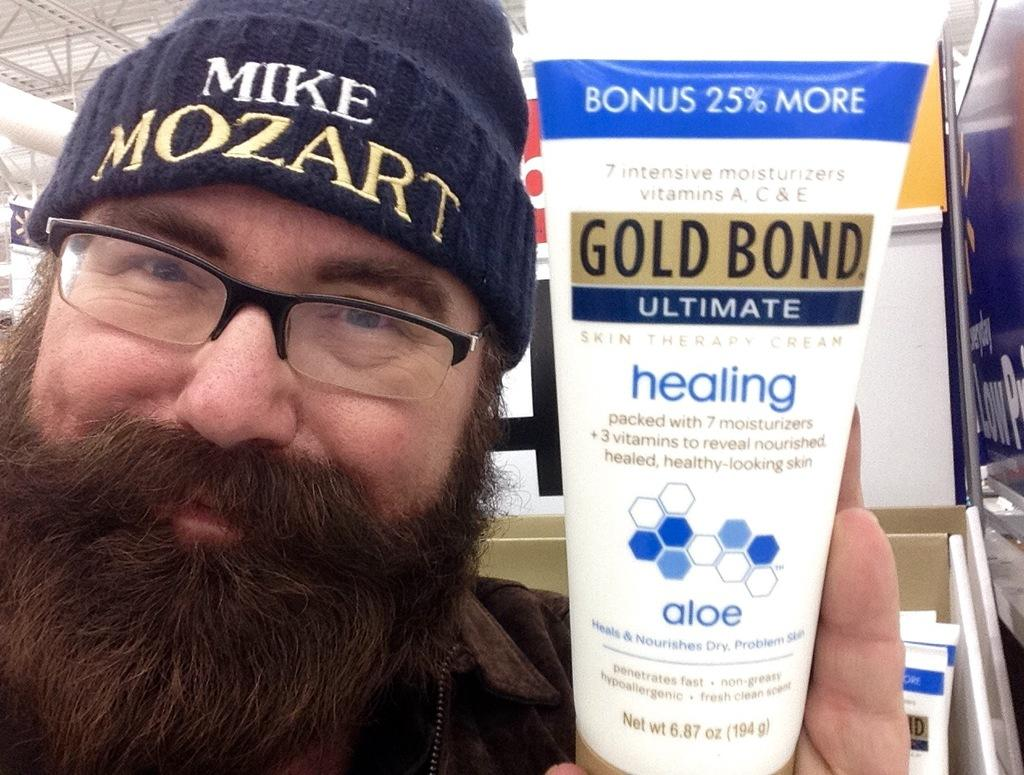<image>
Give a short and clear explanation of the subsequent image. a man with a beard is holding a tube of gold bond healing cream 